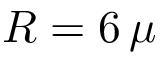<formula> <loc_0><loc_0><loc_500><loc_500>R = 6 \, \mu</formula> 